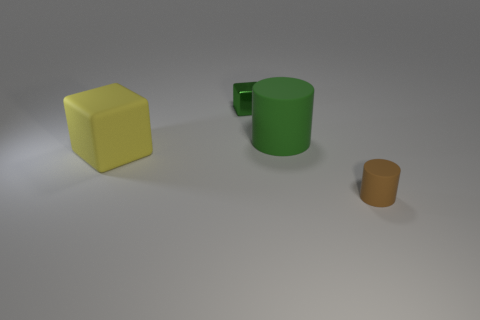What shape is the small object that is the same color as the large cylinder?
Ensure brevity in your answer.  Cube. What is the material of the other object that is the same color as the small metallic object?
Your response must be concise. Rubber. Is there a large green matte object of the same shape as the large yellow object?
Make the answer very short. No. There is a tiny object to the right of the metallic block; does it have the same shape as the big green matte object behind the tiny matte object?
Make the answer very short. Yes. Are there any things of the same size as the green metallic block?
Give a very brief answer. Yes. Are there an equal number of large blocks behind the big matte cube and big green things on the right side of the tiny brown matte object?
Make the answer very short. Yes. Is the material of the green thing that is right of the green block the same as the tiny object in front of the big yellow block?
Make the answer very short. Yes. What material is the green block?
Offer a very short reply. Metal. What number of other objects are there of the same color as the big matte block?
Your response must be concise. 0. Does the metallic block have the same color as the big cylinder?
Provide a succinct answer. Yes. 